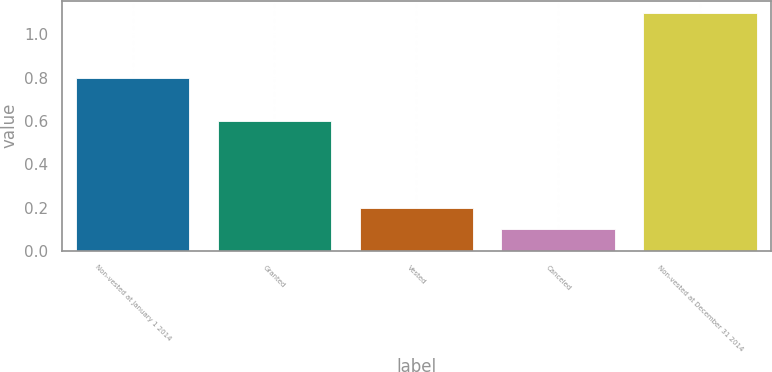Convert chart. <chart><loc_0><loc_0><loc_500><loc_500><bar_chart><fcel>Non-vested at January 1 2014<fcel>Granted<fcel>Vested<fcel>Canceled<fcel>Non-vested at December 31 2014<nl><fcel>0.8<fcel>0.6<fcel>0.2<fcel>0.1<fcel>1.1<nl></chart> 